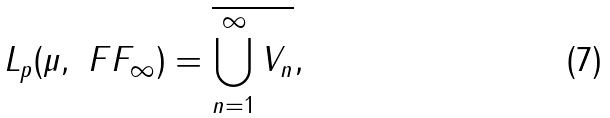Convert formula to latex. <formula><loc_0><loc_0><loc_500><loc_500>L _ { p } ( \mu , \ F F _ { \infty } ) = \overline { \bigcup _ { n = 1 } ^ { \infty } V _ { n } } ,</formula> 